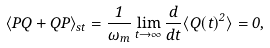Convert formula to latex. <formula><loc_0><loc_0><loc_500><loc_500>\langle P Q + Q P \rangle _ { s t } = \frac { 1 } { \omega _ { m } } \lim _ { t \to \infty } \frac { d } { d t } \langle Q ( t ) ^ { 2 } \rangle = 0 ,</formula> 